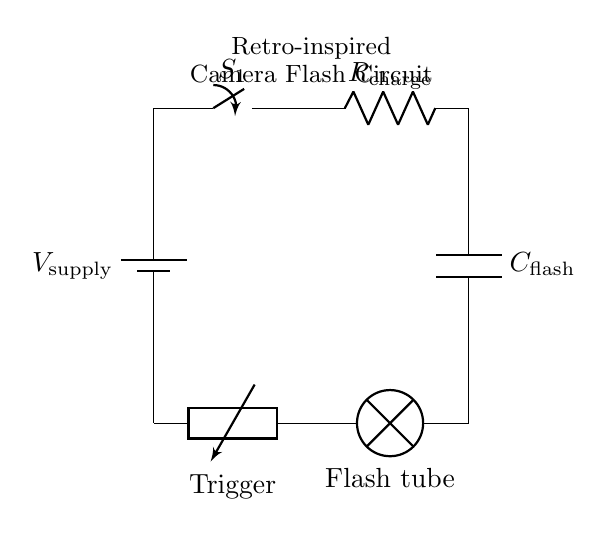What is the primary component used for charging in this circuit? The primary component for charging in this circuit is the resistor labeled R charge, which limits the current flowing into the capacitor during the charging process.
Answer: R charge How many components are used in the flash circuit? The flash circuit consists of five components: a power supply, a switch, a resistor, a capacitor, and a flash tube (lamp). Counting each of these elements gives a total of five.
Answer: five What is the function of the switch in this circuit? The switch labeled S1 controls the flow of current from the power supply to the rest of the circuit, allowing the capacitor to charge or discharging the flash tube when needed.
Answer: control current flow What happens when the trigger circuit is activated? When the trigger circuit is activated, it enables the flash tube to discharge the stored energy from the capacitor, resulting in a bright flash of light. The trigger circuit creates a path to allow this discharge to occur.
Answer: bright flash of light What does the capacitor labeled C flash do in this circuit? The capacitor labeled C flash stores electrical energy when charged, which is later released quickly through the flash tube to produce the flash of light. This is crucial for the functioning of the camera flash.
Answer: stores electrical energy What is the purpose of the lamp in this circuit? The lamp serves as the flash tube that lights up when the capacitor discharges its stored energy, converting the electrical energy into a visible flash of light. This is essential for illumination in photography.
Answer: flash tube How would you describe the overall purpose of this circuit? The overall purpose of this circuit is to store electrical energy in the capacitor and release it in a short burst through the flash tube, providing a bright light for photography purposes, especially in low-light conditions.
Answer: camera flash circuit 